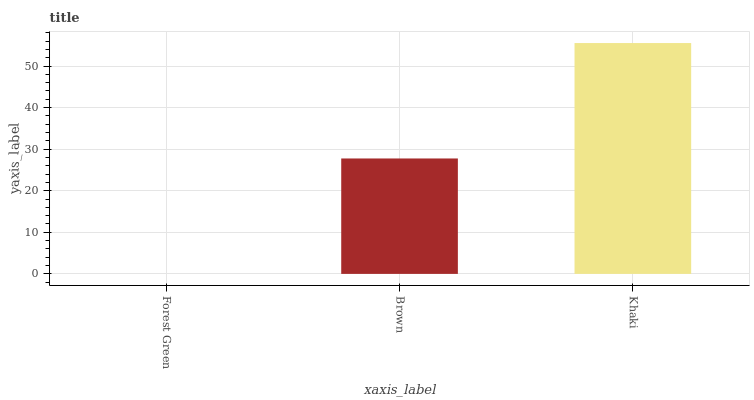Is Forest Green the minimum?
Answer yes or no. Yes. Is Khaki the maximum?
Answer yes or no. Yes. Is Brown the minimum?
Answer yes or no. No. Is Brown the maximum?
Answer yes or no. No. Is Brown greater than Forest Green?
Answer yes or no. Yes. Is Forest Green less than Brown?
Answer yes or no. Yes. Is Forest Green greater than Brown?
Answer yes or no. No. Is Brown less than Forest Green?
Answer yes or no. No. Is Brown the high median?
Answer yes or no. Yes. Is Brown the low median?
Answer yes or no. Yes. Is Forest Green the high median?
Answer yes or no. No. Is Khaki the low median?
Answer yes or no. No. 